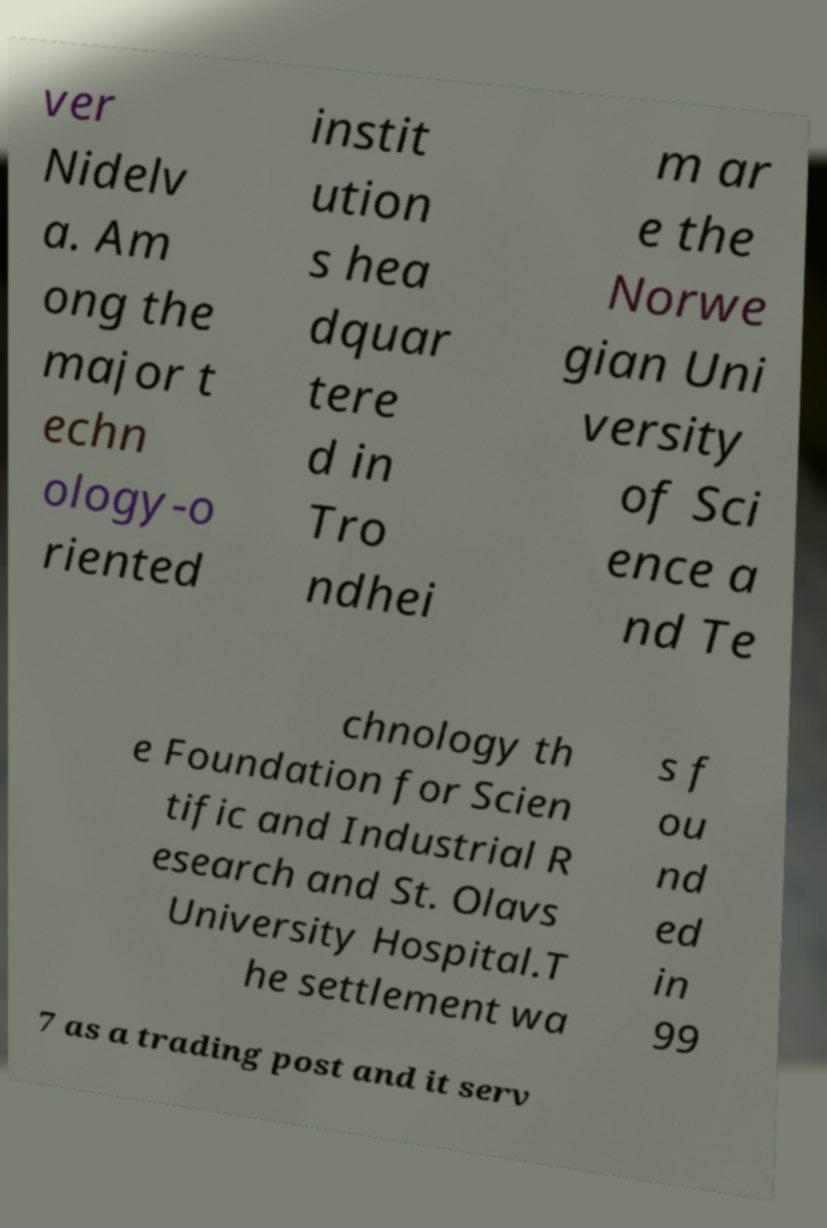What messages or text are displayed in this image? I need them in a readable, typed format. ver Nidelv a. Am ong the major t echn ology-o riented instit ution s hea dquar tere d in Tro ndhei m ar e the Norwe gian Uni versity of Sci ence a nd Te chnology th e Foundation for Scien tific and Industrial R esearch and St. Olavs University Hospital.T he settlement wa s f ou nd ed in 99 7 as a trading post and it serv 